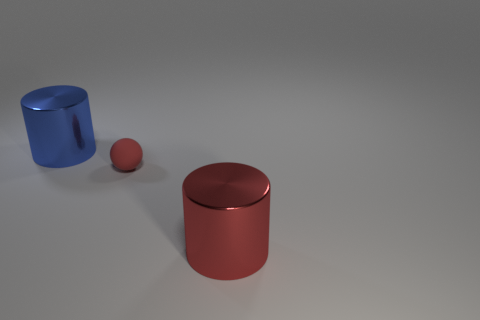What shape is the big red thing?
Give a very brief answer. Cylinder. Are there more large objects behind the small thing than tiny red rubber balls?
Offer a very short reply. No. There is a big metal object that is to the left of the big red cylinder; what shape is it?
Provide a succinct answer. Cylinder. What number of other objects are there of the same shape as the big blue metal object?
Make the answer very short. 1. Is the material of the large object that is on the right side of the blue shiny cylinder the same as the small thing?
Provide a succinct answer. No. Is the number of big blue cylinders to the left of the blue cylinder the same as the number of tiny things that are behind the red rubber thing?
Make the answer very short. Yes. What is the size of the red thing behind the red metal cylinder?
Your answer should be compact. Small. Are there any large things that have the same material as the ball?
Your answer should be very brief. No. There is a metallic object to the right of the blue cylinder; does it have the same color as the rubber sphere?
Your answer should be very brief. Yes. Are there an equal number of shiny things that are to the right of the small sphere and large blue metal objects?
Offer a terse response. Yes. 